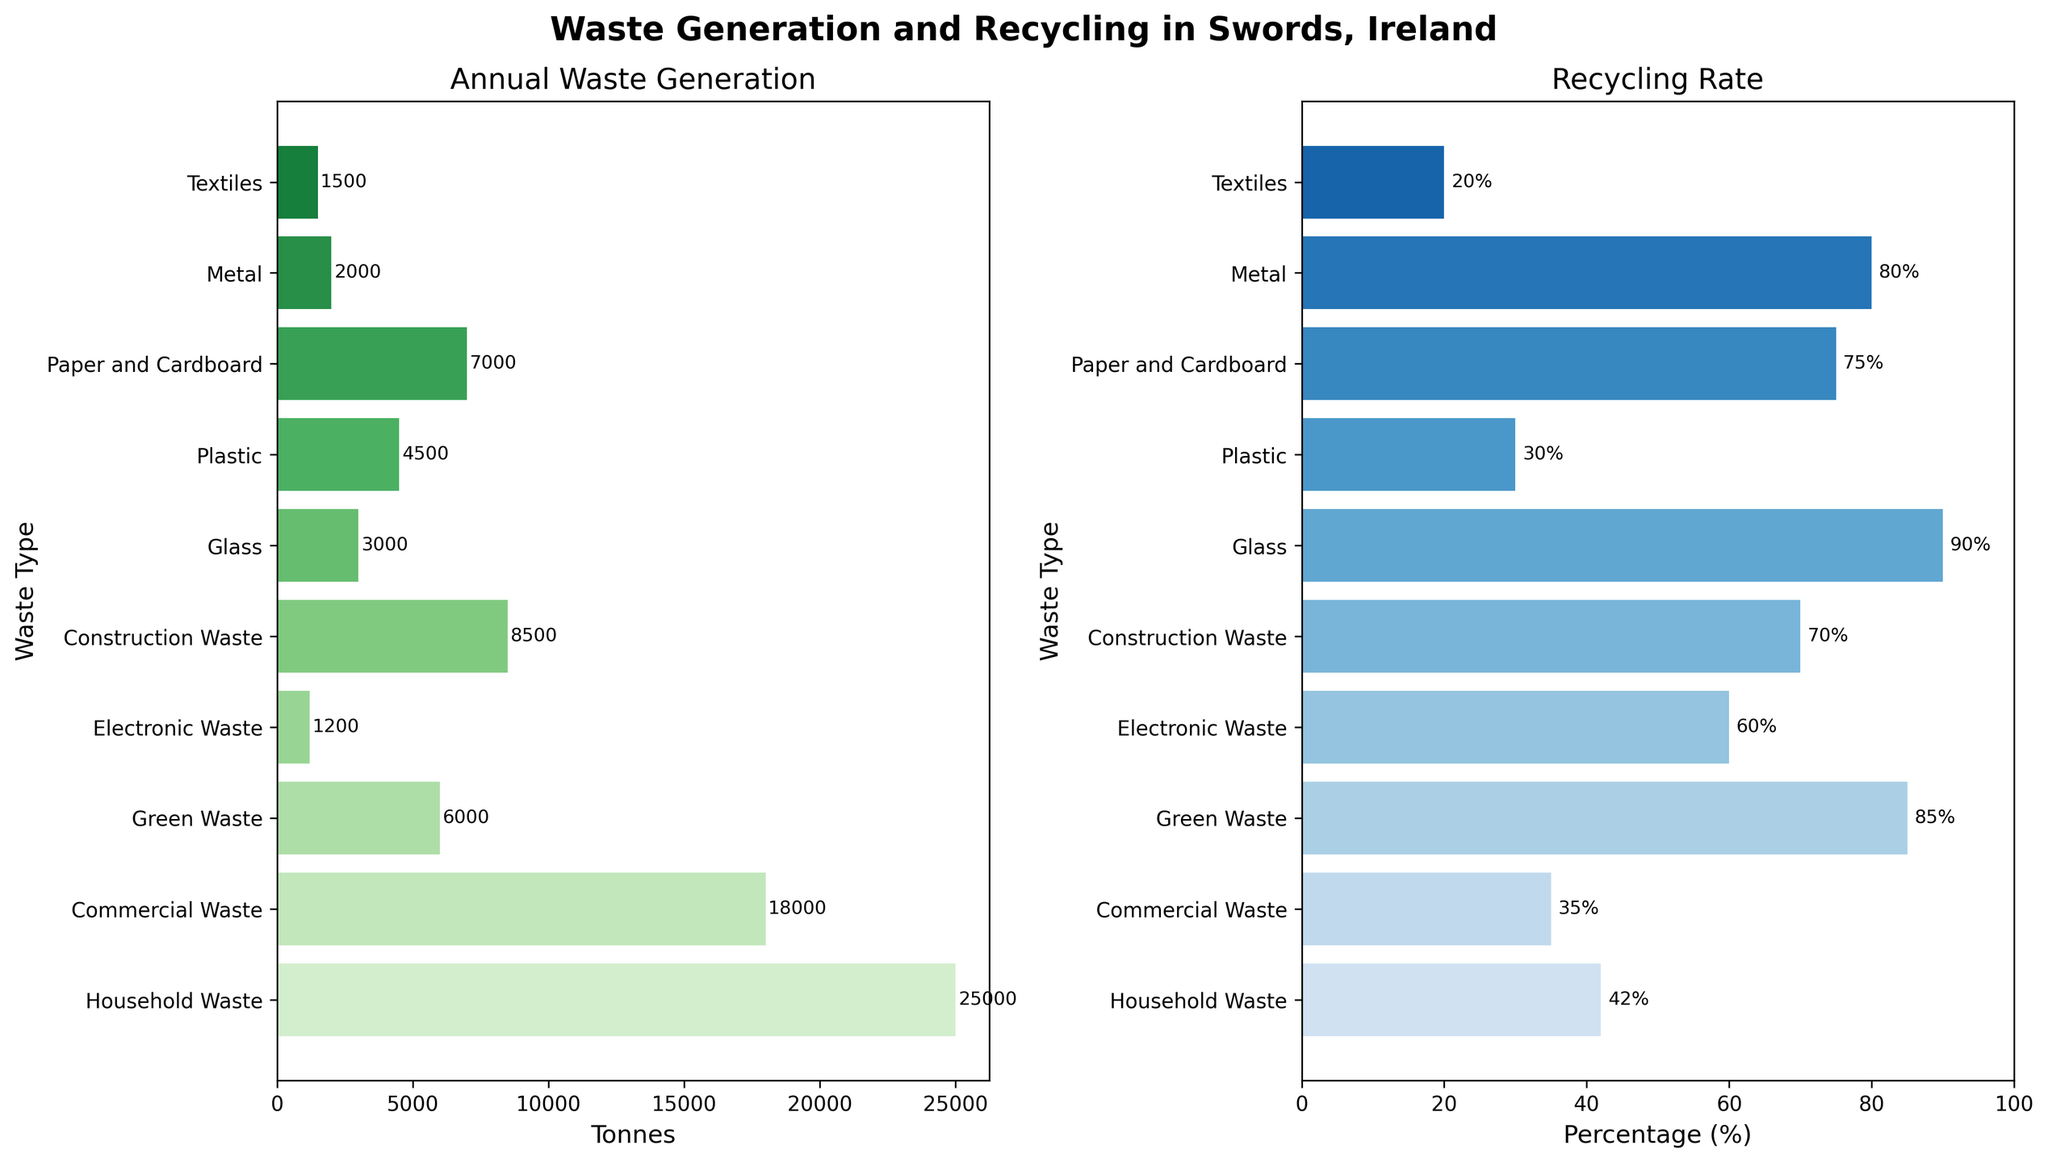What's the total annual waste generation of all waste types? Sum each data point for annual waste generation: 25000 (Household) + 18000 (Commercial) + 6000 (Green) + 1200 (Electronic) + 8500 (Construction) + 3000 (Glass) + 4500 (Plastic) + 7000 (Paper and Cardboard) + 2000 (Metal) + 1500 (Textiles) = 74700 tonnes
Answer: 74700 tonnes Which waste type has the highest recycling rate? Check the recycling rate for each waste type and identify the highest value: Household (42%), Commercial (35%), Green (85%), Electronic (60%), Construction (70%), Glass (90%), Plastic (30%), Paper and Cardboard (75%), Metal (80%), Textiles (20%). Glass has the highest rate at 90%
Answer: Glass What's the difference in recycling rate between Plastic and Paper and Cardboard? Identify the recycling rates: Plastic (30%), Paper and Cardboard (75%). Calculate the difference: 75% - 30% = 45%
Answer: 45% What is the average recycling rate across all waste types? Sum all the recycling rates and divide by the number of data points: (42 + 35 + 85 + 60 + 70 + 90 + 30 + 75 + 80 + 20) / 10 = 58.7%
Answer: 58.7% Which waste type has the lowest annual generation, and how much is it? Check the values for annual generation and identify the smallest one: Household (25000), Commercial (18000), Green (6000), Electronic (1200), Construction (8500), Glass (3000), Plastic (4500), Paper and Cardboard (7000), Metal (2000), Textiles (1500). The smallest value is Electronic Waste at 1200 tonnes
Answer: Electronic Waste, 1200 tonnes Are there any waste types where both annual generation and recycling rate are low? Identify waste types with both low annual generation and low recycling rates. Define "low" as below average: Average generation = 7470 tonnes, Average recycling rate = 58.7%. Electronic Waste (1200 tonnes, 60%), Glass (3000 tonnes, 90%), Metal (2000 tonnes, 80%) and Textiles (1500 tonnes, 20%). Only Textiles fits both criteria
Answer: Textiles How many waste types have a recycling rate above 50%? Count all the waste types with a recycling rate above 50%: Household (42%), Commercial (35%), Green (85%), Electronic (60%), Construction (70%), Glass (90%), Plastic (30%), Paper and Cardboard (75%), Metal (80%), Textiles (20%). There are 6 such types
Answer: 6 Which waste types have higher recycling rates than Household Waste? Check recycling rates and identify those higher than Household Waste (42%): Green (85%), Electronic (60%), Construction (70%), Glass (90%), Paper and Cardboard (75%), Metal (80%)
Answer: Green, Electronic, Construction, Glass, Paper and Cardboard, Metal What proportion of the total annual waste generation is contributed by Commercial Waste? Calculate the proportion: Commercial (18000 tonnes) / Total (74700 tonnes) × 100% = 24.1%
Answer: 24.1% What's the title of the subgraph showing annual waste generation? The title is specified in the plot configuration. It reads "Annual Waste Generation"
Answer: Annual Waste Generation 